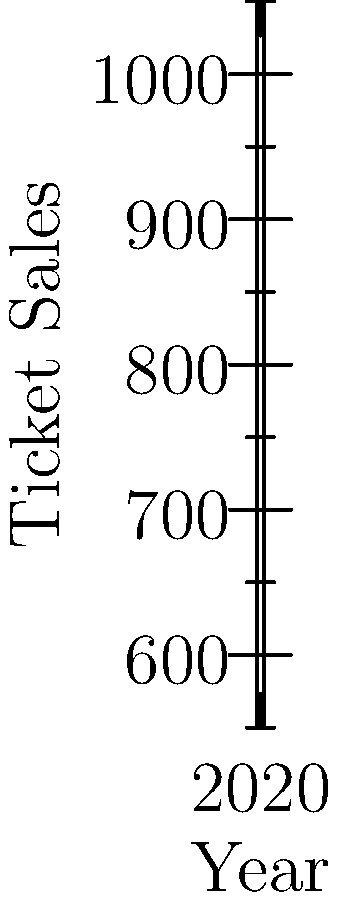As a classical music critic, you've been analyzing ticket sales data for traditional Viennese concerts over the past five years. The graph shows the trend in ticket sales from 2018 to 2022. Calculate the slope of the line representing this trend. How does this slope reflect the changing interest in classical concerts, and how might this relate to the reception of contemporary composers like Nancy Van de Vate? To calculate the slope of the line, we'll use the formula:

$$ \text{slope} = \frac{y_2 - y_1}{x_2 - x_1} $$

Where $(x_1, y_1)$ is the first point and $(x_2, y_2)$ is the last point on the line.

From the graph:
$(x_1, y_1) = (2018, 1000)$
$(x_2, y_2) = (2022, 600)$

Plugging these values into the formula:

$$ \text{slope} = \frac{600 - 1000}{2022 - 2018} = \frac{-400}{4} = -100 $$

The slope is -100, which means ticket sales are decreasing by 100 tickets per year on average.

This negative slope indicates a declining interest in traditional classical concerts. As a critic skeptical of Nancy Van de Vate's works, you might interpret this as:

1. A general decline in interest for classical music, including contemporary composers.
2. A potential opportunity for contemporary composers like Van de Vate to attract new audiences.
3. A need for the classical music scene to evolve, though you might be cautious about how this evolution should occur.

The steep decline might reinforce your skepticism about new compositional styles, as they haven't reversed the trend. Alternatively, it could suggest that traditional programming isn't engaging audiences, potentially opening the door for more contemporary works.
Answer: -100 tickets/year 